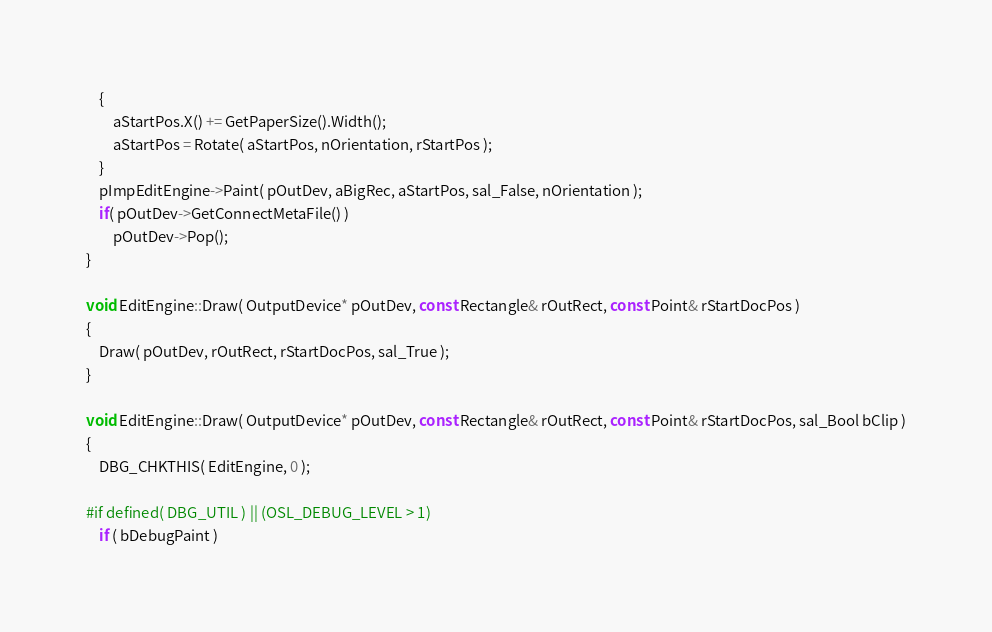<code> <loc_0><loc_0><loc_500><loc_500><_C++_>	{
		aStartPos.X() += GetPaperSize().Width();
		aStartPos = Rotate( aStartPos, nOrientation, rStartPos );
	}
	pImpEditEngine->Paint( pOutDev, aBigRec, aStartPos, sal_False, nOrientation );
	if( pOutDev->GetConnectMetaFile() )
		pOutDev->Pop();
}

void EditEngine::Draw( OutputDevice* pOutDev, const Rectangle& rOutRect, const Point& rStartDocPos )
{
	Draw( pOutDev, rOutRect, rStartDocPos, sal_True );
}

void EditEngine::Draw( OutputDevice* pOutDev, const Rectangle& rOutRect, const Point& rStartDocPos, sal_Bool bClip )
{
	DBG_CHKTHIS( EditEngine, 0 );

#if defined( DBG_UTIL ) || (OSL_DEBUG_LEVEL > 1)
	if ( bDebugPaint )</code> 